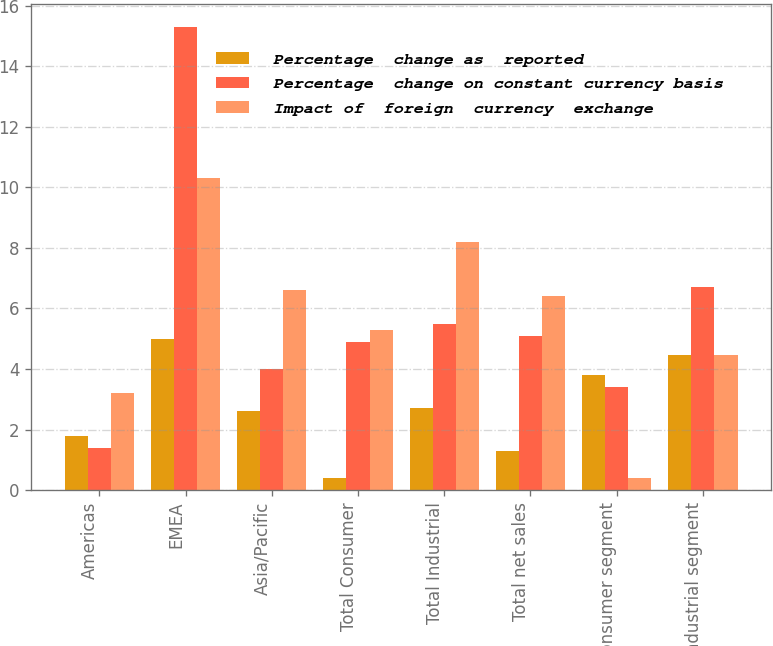Convert chart to OTSL. <chart><loc_0><loc_0><loc_500><loc_500><stacked_bar_chart><ecel><fcel>Americas<fcel>EMEA<fcel>Asia/Pacific<fcel>Total Consumer<fcel>Total Industrial<fcel>Total net sales<fcel>Consumer segment<fcel>Industrial segment<nl><fcel>Percentage  change as  reported<fcel>1.8<fcel>5<fcel>2.6<fcel>0.4<fcel>2.7<fcel>1.3<fcel>3.8<fcel>4.45<nl><fcel>Percentage  change on constant currency basis<fcel>1.4<fcel>15.3<fcel>4<fcel>4.9<fcel>5.5<fcel>5.1<fcel>3.4<fcel>6.7<nl><fcel>Impact of  foreign  currency  exchange<fcel>3.2<fcel>10.3<fcel>6.6<fcel>5.3<fcel>8.2<fcel>6.4<fcel>0.4<fcel>4.45<nl></chart> 